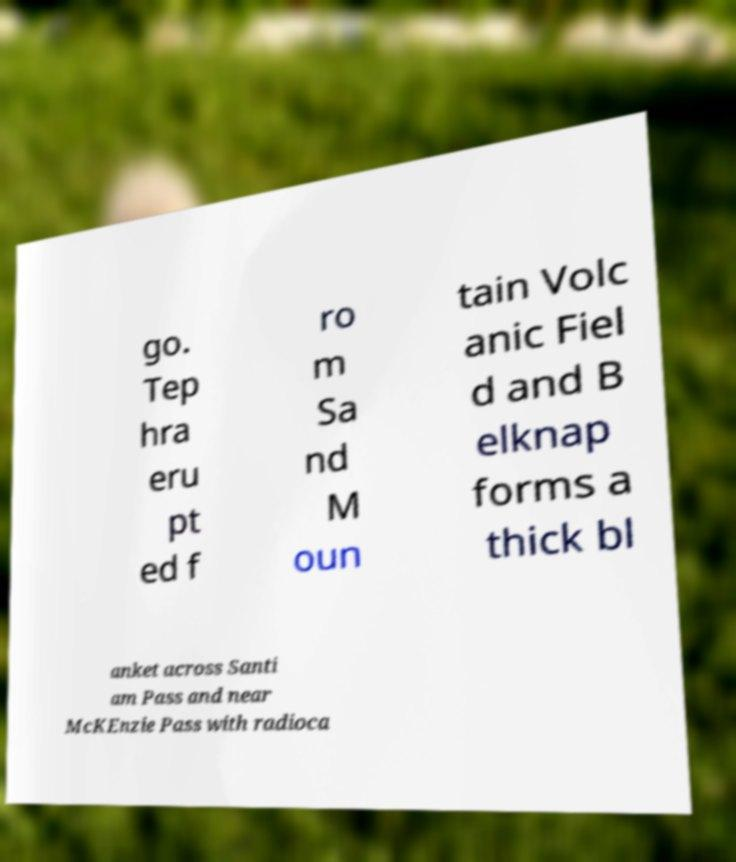For documentation purposes, I need the text within this image transcribed. Could you provide that? go. Tep hra eru pt ed f ro m Sa nd M oun tain Volc anic Fiel d and B elknap forms a thick bl anket across Santi am Pass and near McKEnzie Pass with radioca 